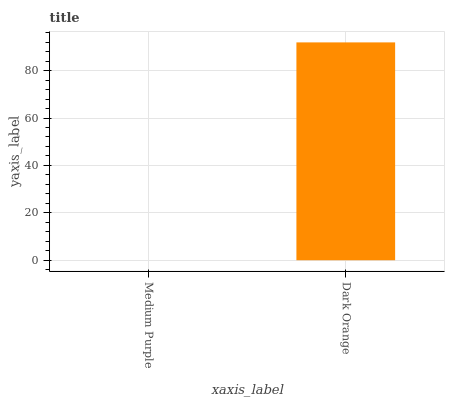Is Medium Purple the minimum?
Answer yes or no. Yes. Is Dark Orange the maximum?
Answer yes or no. Yes. Is Dark Orange the minimum?
Answer yes or no. No. Is Dark Orange greater than Medium Purple?
Answer yes or no. Yes. Is Medium Purple less than Dark Orange?
Answer yes or no. Yes. Is Medium Purple greater than Dark Orange?
Answer yes or no. No. Is Dark Orange less than Medium Purple?
Answer yes or no. No. Is Dark Orange the high median?
Answer yes or no. Yes. Is Medium Purple the low median?
Answer yes or no. Yes. Is Medium Purple the high median?
Answer yes or no. No. Is Dark Orange the low median?
Answer yes or no. No. 